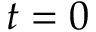Convert formula to latex. <formula><loc_0><loc_0><loc_500><loc_500>t = 0</formula> 